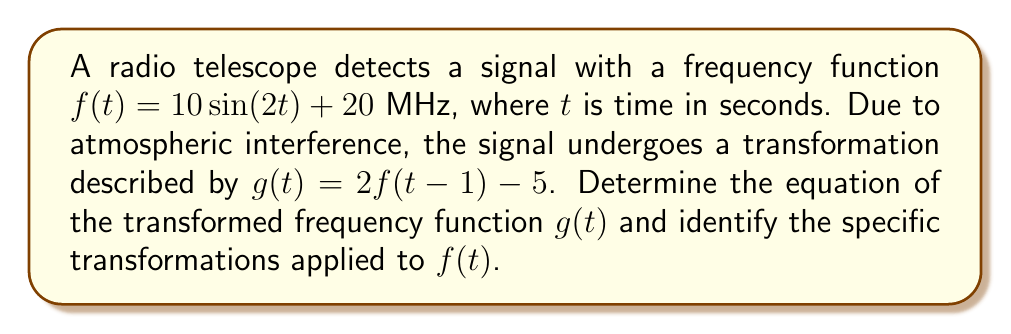Can you answer this question? Let's approach this step-by-step:

1) We start with the original function: $f(t) = 10\sin(2t) + 20$

2) The transformation is given by $g(t) = 2f(t-1) - 5$

3) Let's apply the transformation:
   $g(t) = 2[10\sin(2(t-1)) + 20] - 5$

4) Simplify inside the brackets:
   $g(t) = 2[10\sin(2t-2) + 20] - 5$

5) Distribute the 2:
   $g(t) = 20\sin(2t-2) + 40 - 5$

6) Simplify:
   $g(t) = 20\sin(2t-2) + 35$

Now, let's identify the transformations:

a) The amplitude is doubled (coefficient of sine changed from 10 to 20)
b) There's a phase shift of 1 unit to the right (t-1 inside sine)
c) The vertical shift is increased by 15 units (from +20 to +35)
Answer: $g(t) = 20\sin(2t-2) + 35$; Amplitude doubled, phase shift right by 1, vertical shift up by 15 